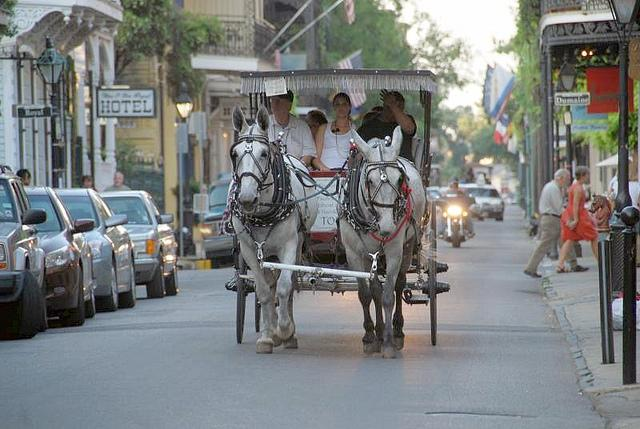Why are there horses in front of the carriage?

Choices:
A) to pull
B) to pet
C) to ride
D) to eat to pull 